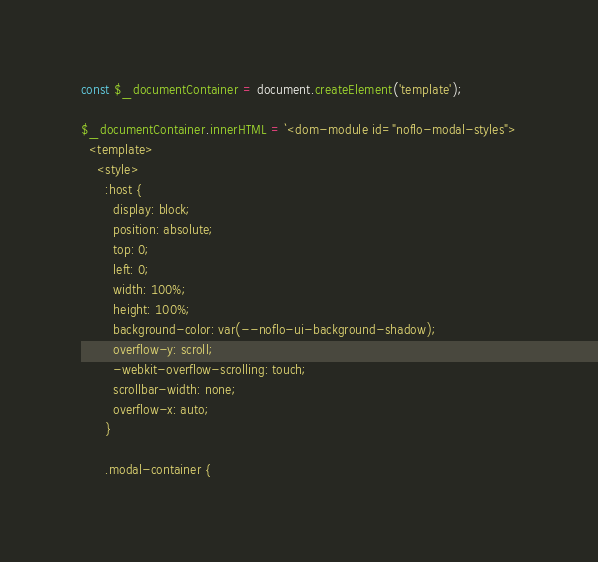Convert code to text. <code><loc_0><loc_0><loc_500><loc_500><_JavaScript_>const $_documentContainer = document.createElement('template');

$_documentContainer.innerHTML = `<dom-module id="noflo-modal-styles">
  <template>
    <style>
      :host {
        display: block;
        position: absolute;
        top: 0;
        left: 0;
        width: 100%;
        height: 100%;
        background-color: var(--noflo-ui-background-shadow);
        overflow-y: scroll;
        -webkit-overflow-scrolling: touch;
        scrollbar-width: none;
        overflow-x: auto;
      }

      .modal-container {</code> 